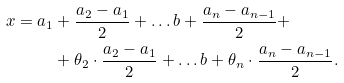Convert formula to latex. <formula><loc_0><loc_0><loc_500><loc_500>x = a _ { 1 } & + \frac { a _ { 2 } - a _ { 1 } } { 2 } + \dots b + \frac { a _ { n } - a _ { n - 1 } } { 2 } + \\ & + \theta _ { 2 } \cdot \frac { a _ { 2 } - a _ { 1 } } { 2 } + \dots b + \theta _ { n } \cdot \frac { a _ { n } - a _ { n - 1 } } { 2 } .</formula> 